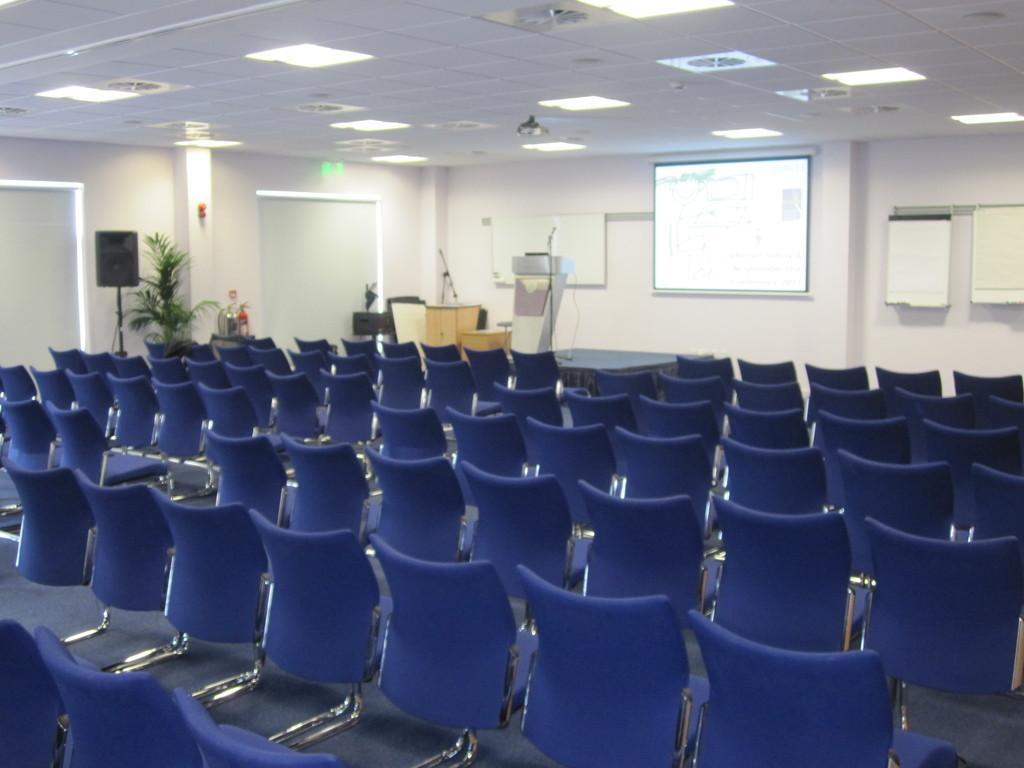How would you summarize this image in a sentence or two? In this image I can see few chairs in blue color, background I can see a projector screen, few papers attached the wall, plants in green color, few lights and the wall is in white color. 